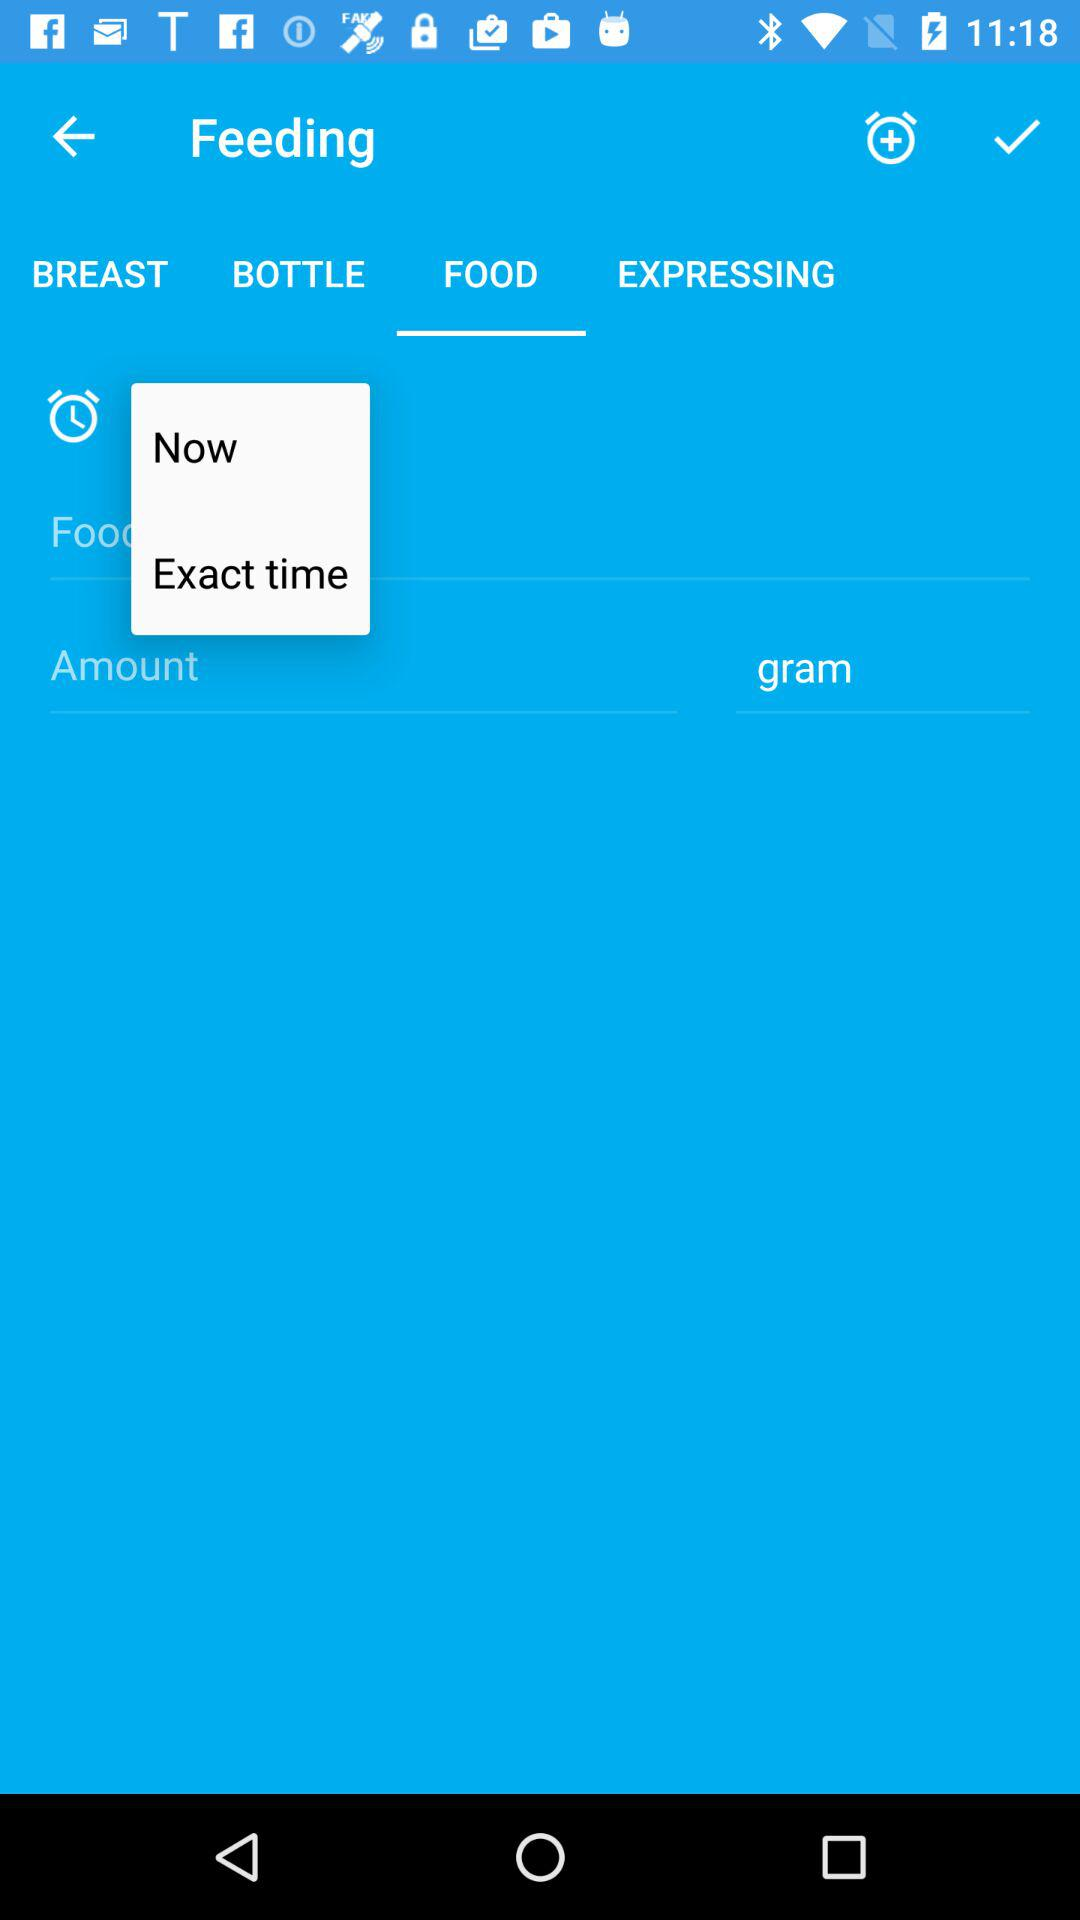What tab is selected? The selected tab is "FOOD". 